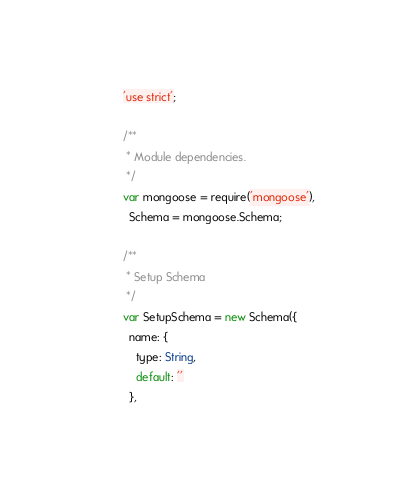<code> <loc_0><loc_0><loc_500><loc_500><_JavaScript_>'use strict';

/**
 * Module dependencies.
 */
var mongoose = require('mongoose'),
  Schema = mongoose.Schema;

/**
 * Setup Schema
 */
var SetupSchema = new Schema({
  name: {
    type: String,
    default: ''
  },</code> 